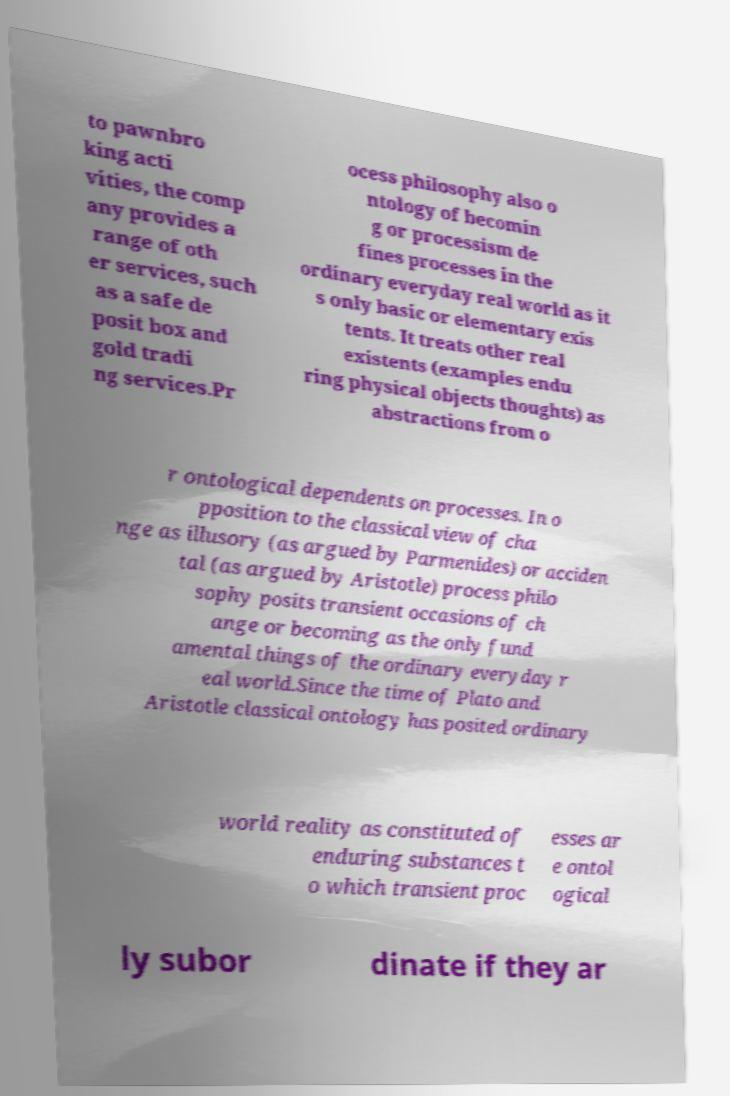Could you assist in decoding the text presented in this image and type it out clearly? to pawnbro king acti vities, the comp any provides a range of oth er services, such as a safe de posit box and gold tradi ng services.Pr ocess philosophy also o ntology of becomin g or processism de fines processes in the ordinary everyday real world as it s only basic or elementary exis tents. It treats other real existents (examples endu ring physical objects thoughts) as abstractions from o r ontological dependents on processes. In o pposition to the classical view of cha nge as illusory (as argued by Parmenides) or acciden tal (as argued by Aristotle) process philo sophy posits transient occasions of ch ange or becoming as the only fund amental things of the ordinary everyday r eal world.Since the time of Plato and Aristotle classical ontology has posited ordinary world reality as constituted of enduring substances t o which transient proc esses ar e ontol ogical ly subor dinate if they ar 